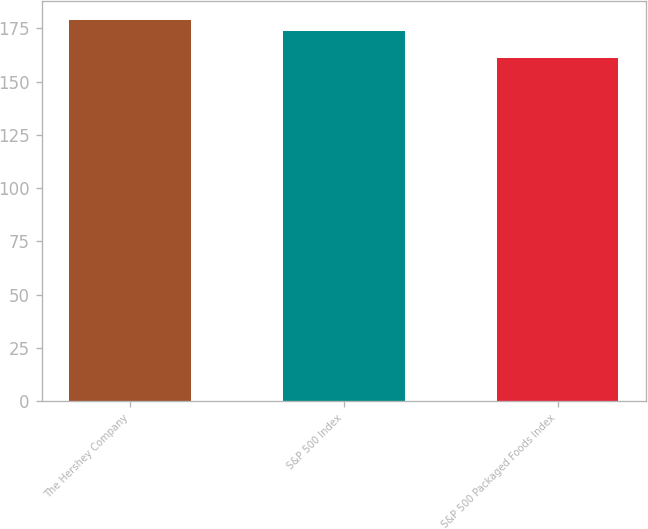Convert chart to OTSL. <chart><loc_0><loc_0><loc_500><loc_500><bar_chart><fcel>The Hershey Company<fcel>S&P 500 Index<fcel>S&P 500 Packaged Foods Index<nl><fcel>179<fcel>174<fcel>161<nl></chart> 